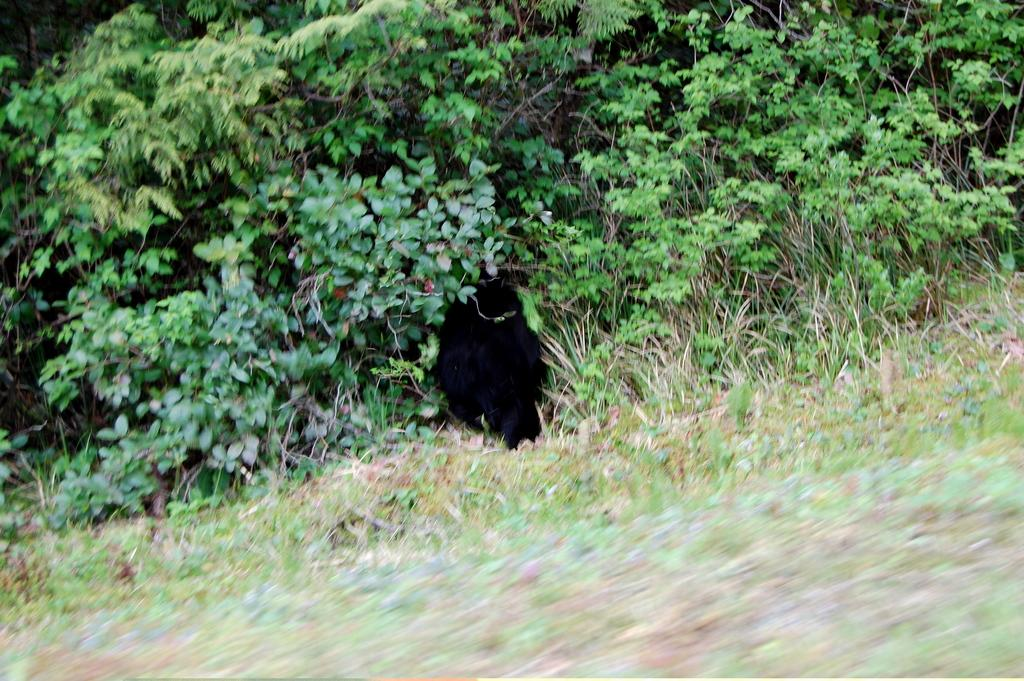What type of vegetation can be seen in the image? There are plants and grass visible in the image. Can you describe the plants in more detail? There are leaves visible on the left side of the image. What is the primary feature of the image? There is a black hole in the center of the image. How many boys are playing on the roof in the image? There are no boys or roof present in the image. 